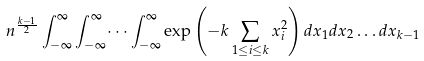Convert formula to latex. <formula><loc_0><loc_0><loc_500><loc_500>n ^ { \frac { k - 1 } { 2 } } \int _ { - \infty } ^ { \infty } \int _ { - \infty } ^ { \infty } \dots \int _ { - \infty } ^ { \infty } \exp \left ( - k \sum _ { 1 \leq i \leq k } x _ { i } ^ { 2 } \right ) d x _ { 1 } d x _ { 2 } \dots d x _ { k - 1 }</formula> 